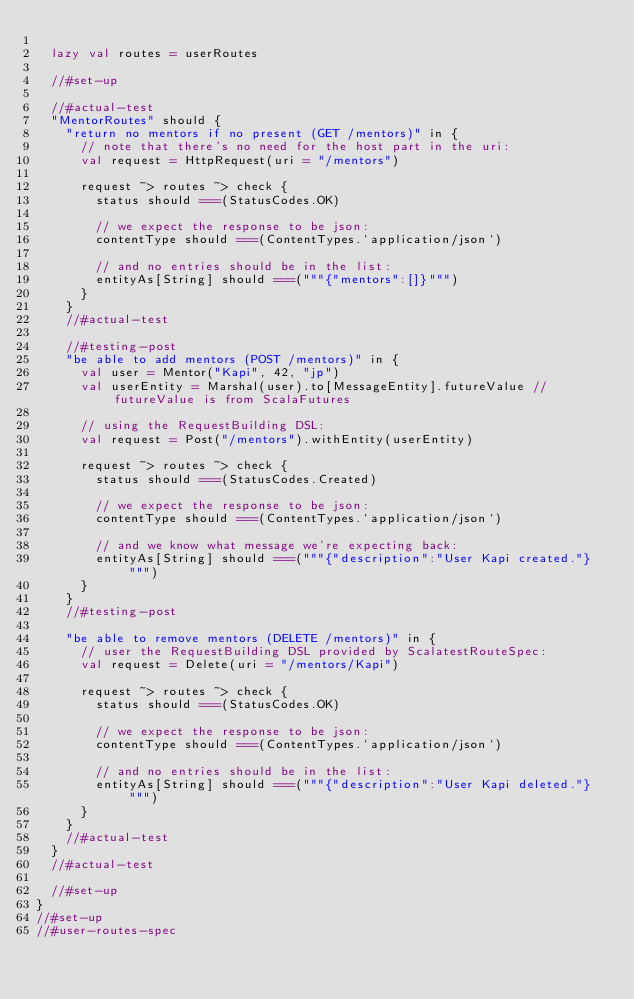<code> <loc_0><loc_0><loc_500><loc_500><_Scala_>
  lazy val routes = userRoutes

  //#set-up

  //#actual-test
  "MentorRoutes" should {
    "return no mentors if no present (GET /mentors)" in {
      // note that there's no need for the host part in the uri:
      val request = HttpRequest(uri = "/mentors")

      request ~> routes ~> check {
        status should ===(StatusCodes.OK)

        // we expect the response to be json:
        contentType should ===(ContentTypes.`application/json`)

        // and no entries should be in the list:
        entityAs[String] should ===("""{"mentors":[]}""")
      }
    }
    //#actual-test

    //#testing-post
    "be able to add mentors (POST /mentors)" in {
      val user = Mentor("Kapi", 42, "jp")
      val userEntity = Marshal(user).to[MessageEntity].futureValue // futureValue is from ScalaFutures

      // using the RequestBuilding DSL:
      val request = Post("/mentors").withEntity(userEntity)

      request ~> routes ~> check {
        status should ===(StatusCodes.Created)

        // we expect the response to be json:
        contentType should ===(ContentTypes.`application/json`)

        // and we know what message we're expecting back:
        entityAs[String] should ===("""{"description":"User Kapi created."}""")
      }
    }
    //#testing-post

    "be able to remove mentors (DELETE /mentors)" in {
      // user the RequestBuilding DSL provided by ScalatestRouteSpec:
      val request = Delete(uri = "/mentors/Kapi")

      request ~> routes ~> check {
        status should ===(StatusCodes.OK)

        // we expect the response to be json:
        contentType should ===(ContentTypes.`application/json`)

        // and no entries should be in the list:
        entityAs[String] should ===("""{"description":"User Kapi deleted."}""")
      }
    }
    //#actual-test
  }
  //#actual-test

  //#set-up
}
//#set-up
//#user-routes-spec
</code> 